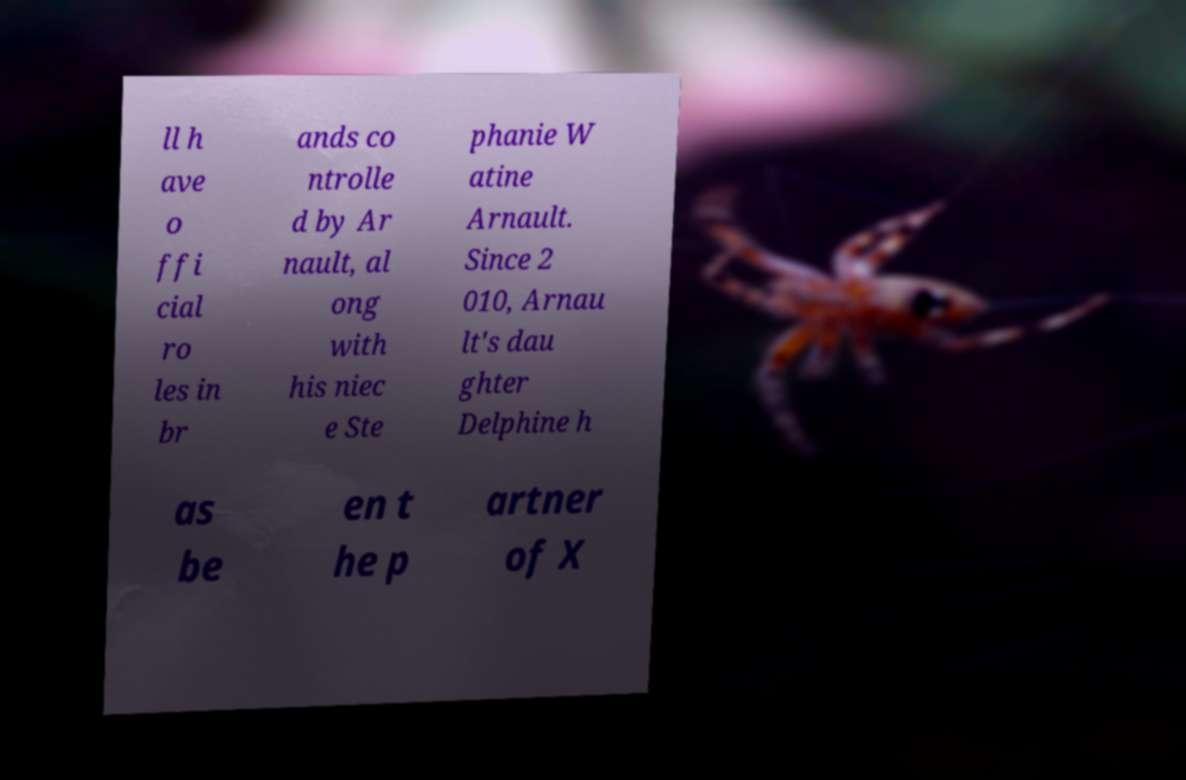There's text embedded in this image that I need extracted. Can you transcribe it verbatim? ll h ave o ffi cial ro les in br ands co ntrolle d by Ar nault, al ong with his niec e Ste phanie W atine Arnault. Since 2 010, Arnau lt's dau ghter Delphine h as be en t he p artner of X 